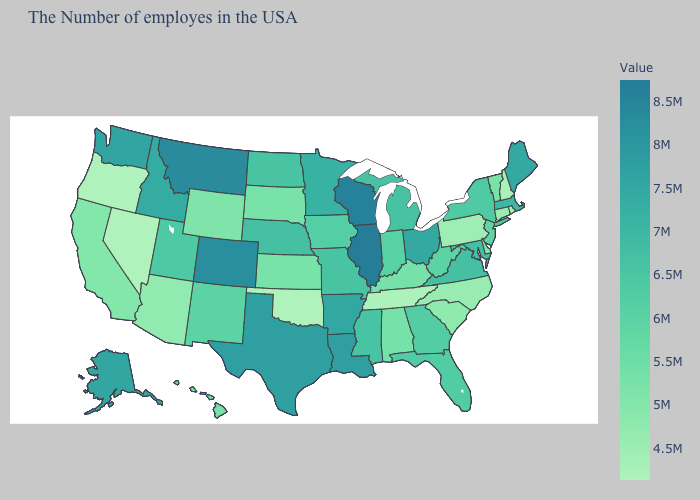Among the states that border Maryland , which have the lowest value?
Write a very short answer. Pennsylvania. Does the map have missing data?
Answer briefly. No. Does Illinois have the highest value in the USA?
Concise answer only. Yes. Is the legend a continuous bar?
Write a very short answer. Yes. Which states have the highest value in the USA?
Write a very short answer. Illinois. Among the states that border Utah , does New Mexico have the highest value?
Quick response, please. No. 